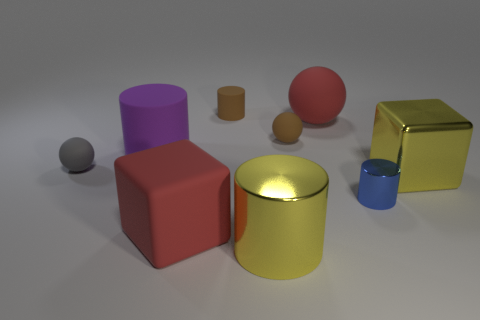There is a tiny gray object that is made of the same material as the purple object; what is its shape? The tiny gray object is spherical in shape, resembling a small ball. It shares the same smooth and matte surface texture as the larger purple object nearby, which is cylindrical. 